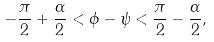<formula> <loc_0><loc_0><loc_500><loc_500>- \frac { \pi } { 2 } + \frac { \alpha } { 2 } < \phi - \psi < \frac { \pi } { 2 } - \frac { \alpha } { 2 } ,</formula> 